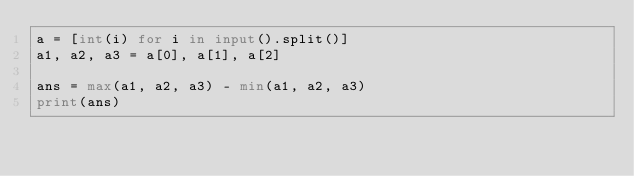<code> <loc_0><loc_0><loc_500><loc_500><_Python_>a = [int(i) for i in input().split()]
a1, a2, a3 = a[0], a[1], a[2]

ans = max(a1, a2, a3) - min(a1, a2, a3)
print(ans)</code> 